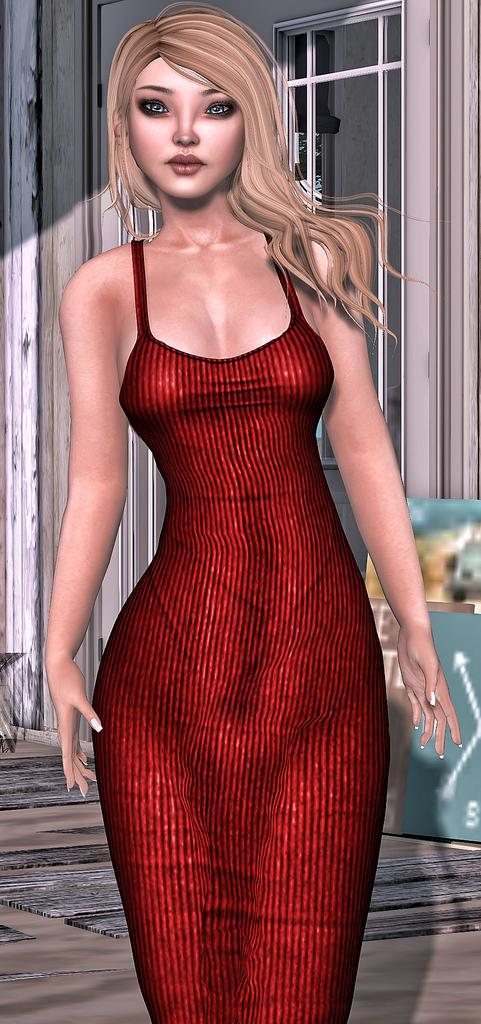What type of image is being described? The image is an animated picture. Can you describe the characters or subjects in the image? There is a woman in the image. How many bears are present in the image? There are no bears present in the image; it only features a woman. What year was the image created? The provided facts do not mention the year the image was created, so it cannot be determined from the information given. 